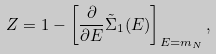<formula> <loc_0><loc_0><loc_500><loc_500>Z = 1 - \left [ \frac { \partial } { \partial E } \tilde { \Sigma } _ { 1 } ( E ) \right ] _ { E = m _ { N } } ,</formula> 